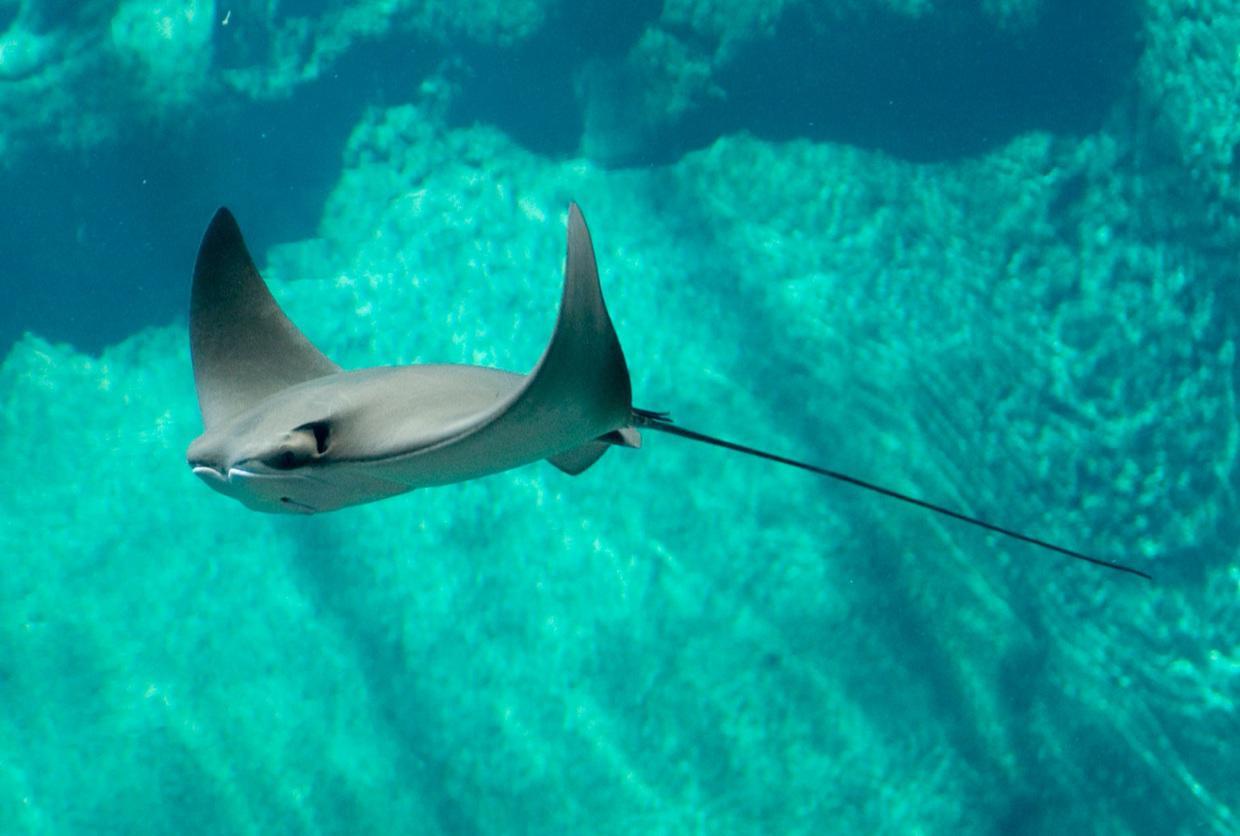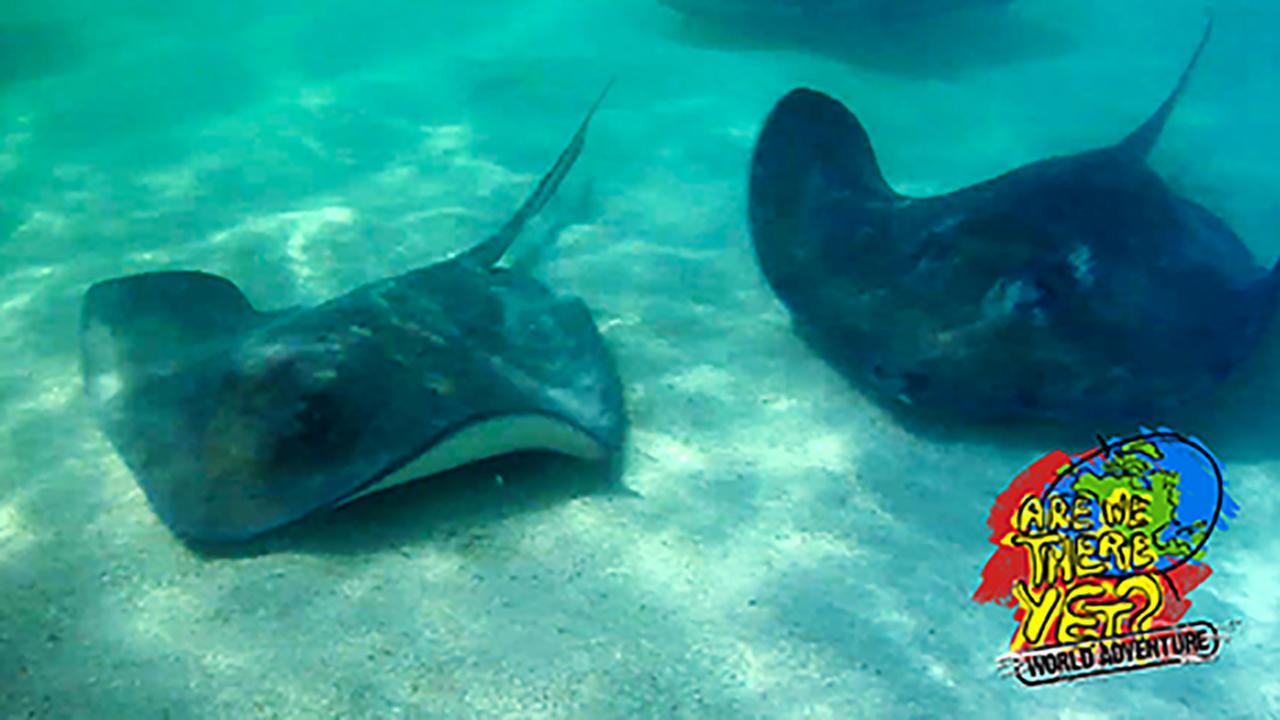The first image is the image on the left, the second image is the image on the right. Given the left and right images, does the statement "Two stingrays are swimming on the floor of the sea in the image on the right." hold true? Answer yes or no. Yes. 